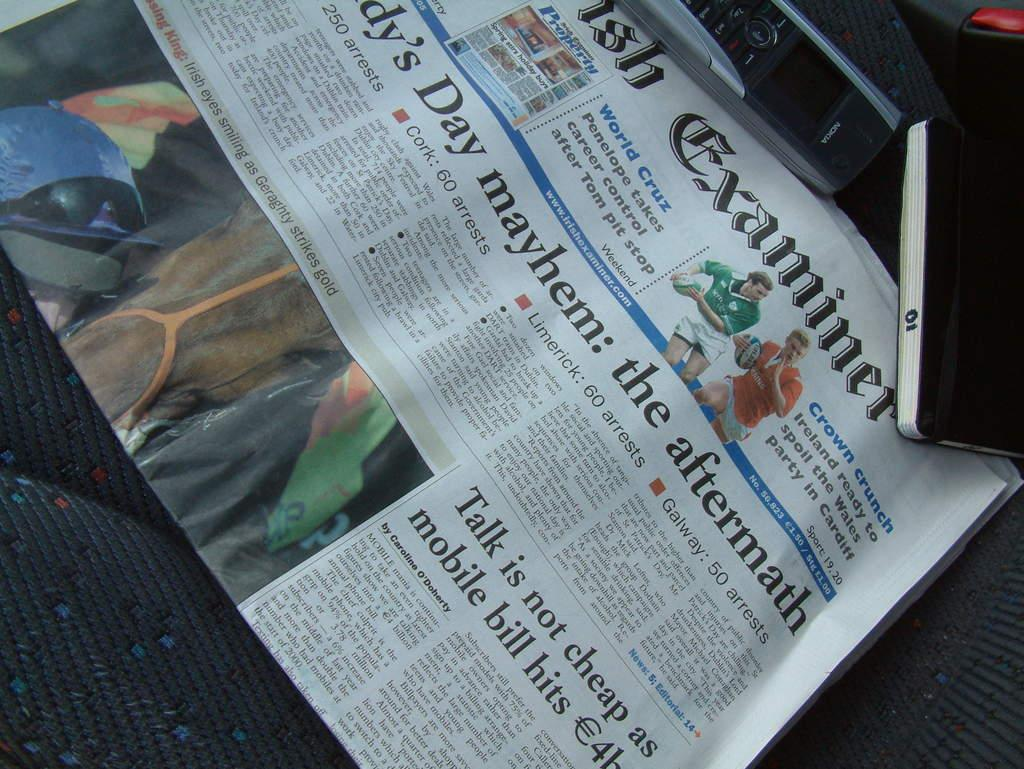<image>
Write a terse but informative summary of the picture. A newspaper that has the word examiner its name. 